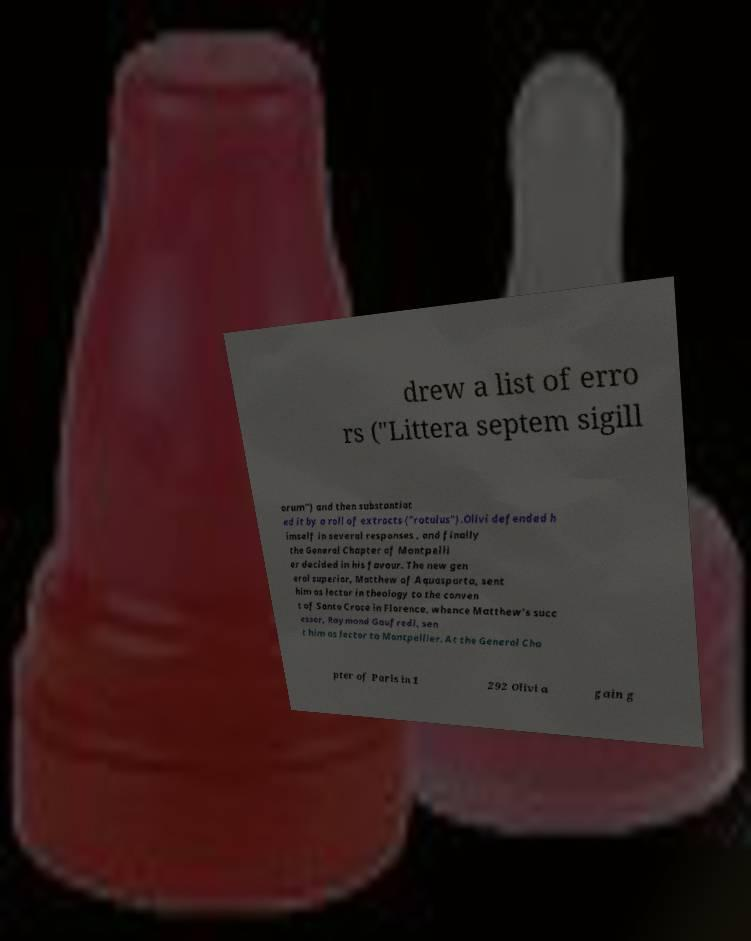Can you accurately transcribe the text from the provided image for me? drew a list of erro rs ("Littera septem sigill orum") and then substantiat ed it by a roll of extracts ("rotulus").Olivi defended h imself in several responses , and finally the General Chapter of Montpelli er decided in his favour. The new gen eral superior, Matthew of Aquasparta, sent him as lector in theology to the conven t of Santa Croce in Florence, whence Matthew's succ essor, Raymond Gaufredi, sen t him as lector to Montpellier. At the General Cha pter of Paris in 1 292 Olivi a gain g 